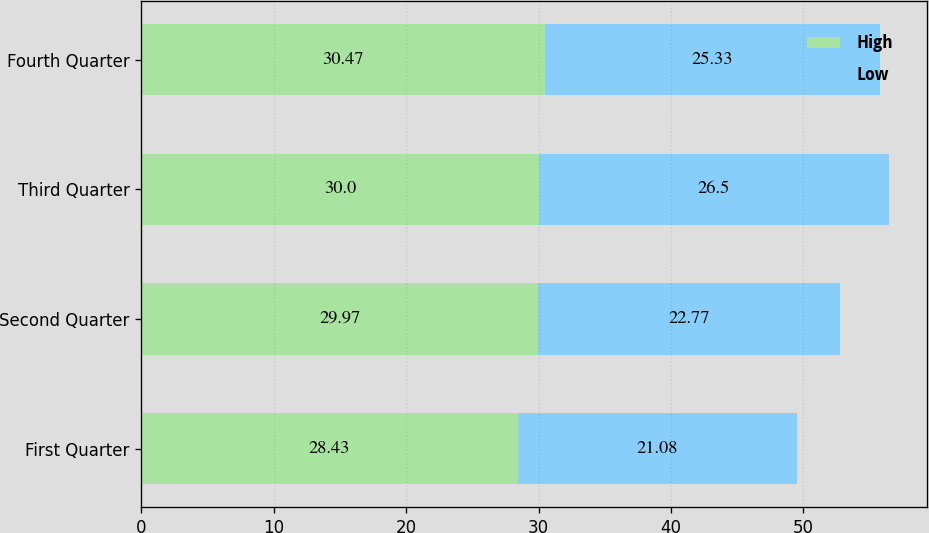<chart> <loc_0><loc_0><loc_500><loc_500><stacked_bar_chart><ecel><fcel>First Quarter<fcel>Second Quarter<fcel>Third Quarter<fcel>Fourth Quarter<nl><fcel>High<fcel>28.43<fcel>29.97<fcel>30<fcel>30.47<nl><fcel>Low<fcel>21.08<fcel>22.77<fcel>26.5<fcel>25.33<nl></chart> 